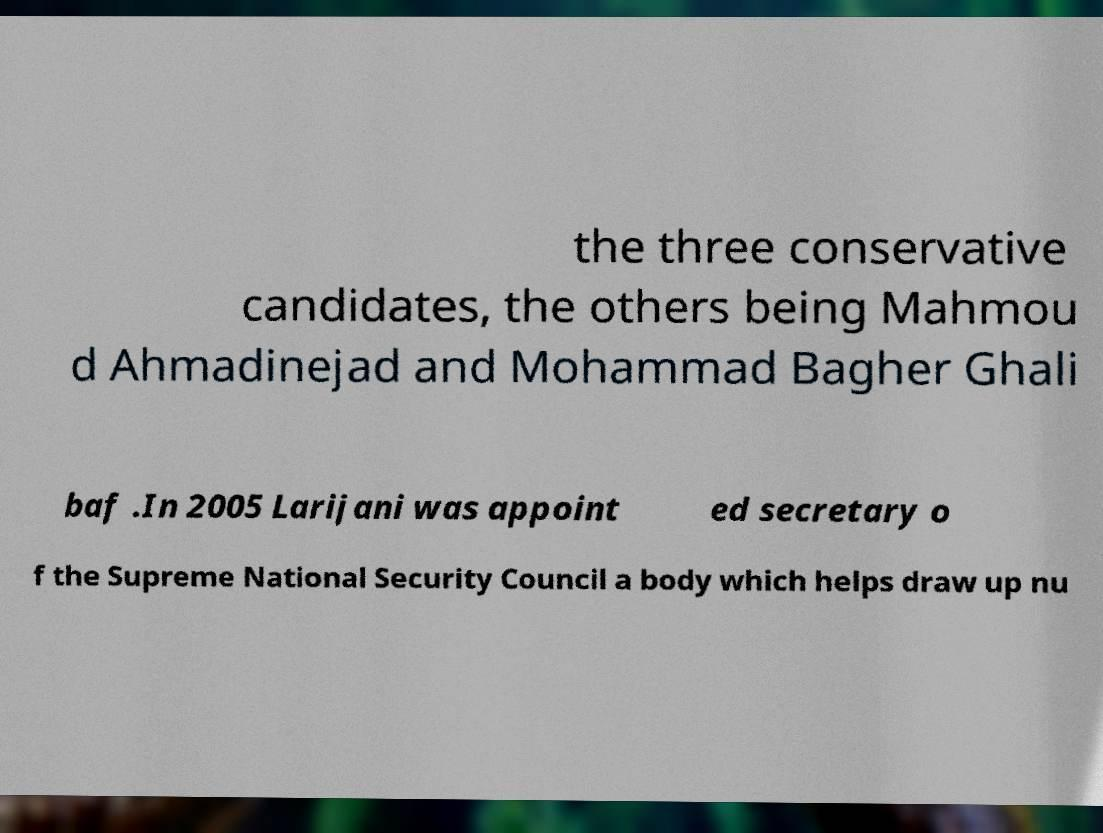There's text embedded in this image that I need extracted. Can you transcribe it verbatim? the three conservative candidates, the others being Mahmou d Ahmadinejad and Mohammad Bagher Ghali baf .In 2005 Larijani was appoint ed secretary o f the Supreme National Security Council a body which helps draw up nu 